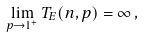<formula> <loc_0><loc_0><loc_500><loc_500>\lim _ { p \to 1 ^ { + } } T _ { E } ( n , p ) = \infty \, ,</formula> 